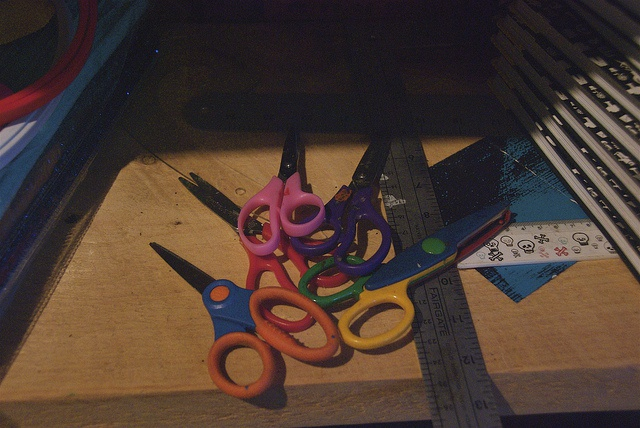Describe the objects in this image and their specific colors. I can see scissors in black, brown, maroon, and navy tones, scissors in black, olive, navy, and maroon tones, scissors in black, navy, maroon, and gray tones, scissors in black, brown, and maroon tones, and book in black and gray tones in this image. 